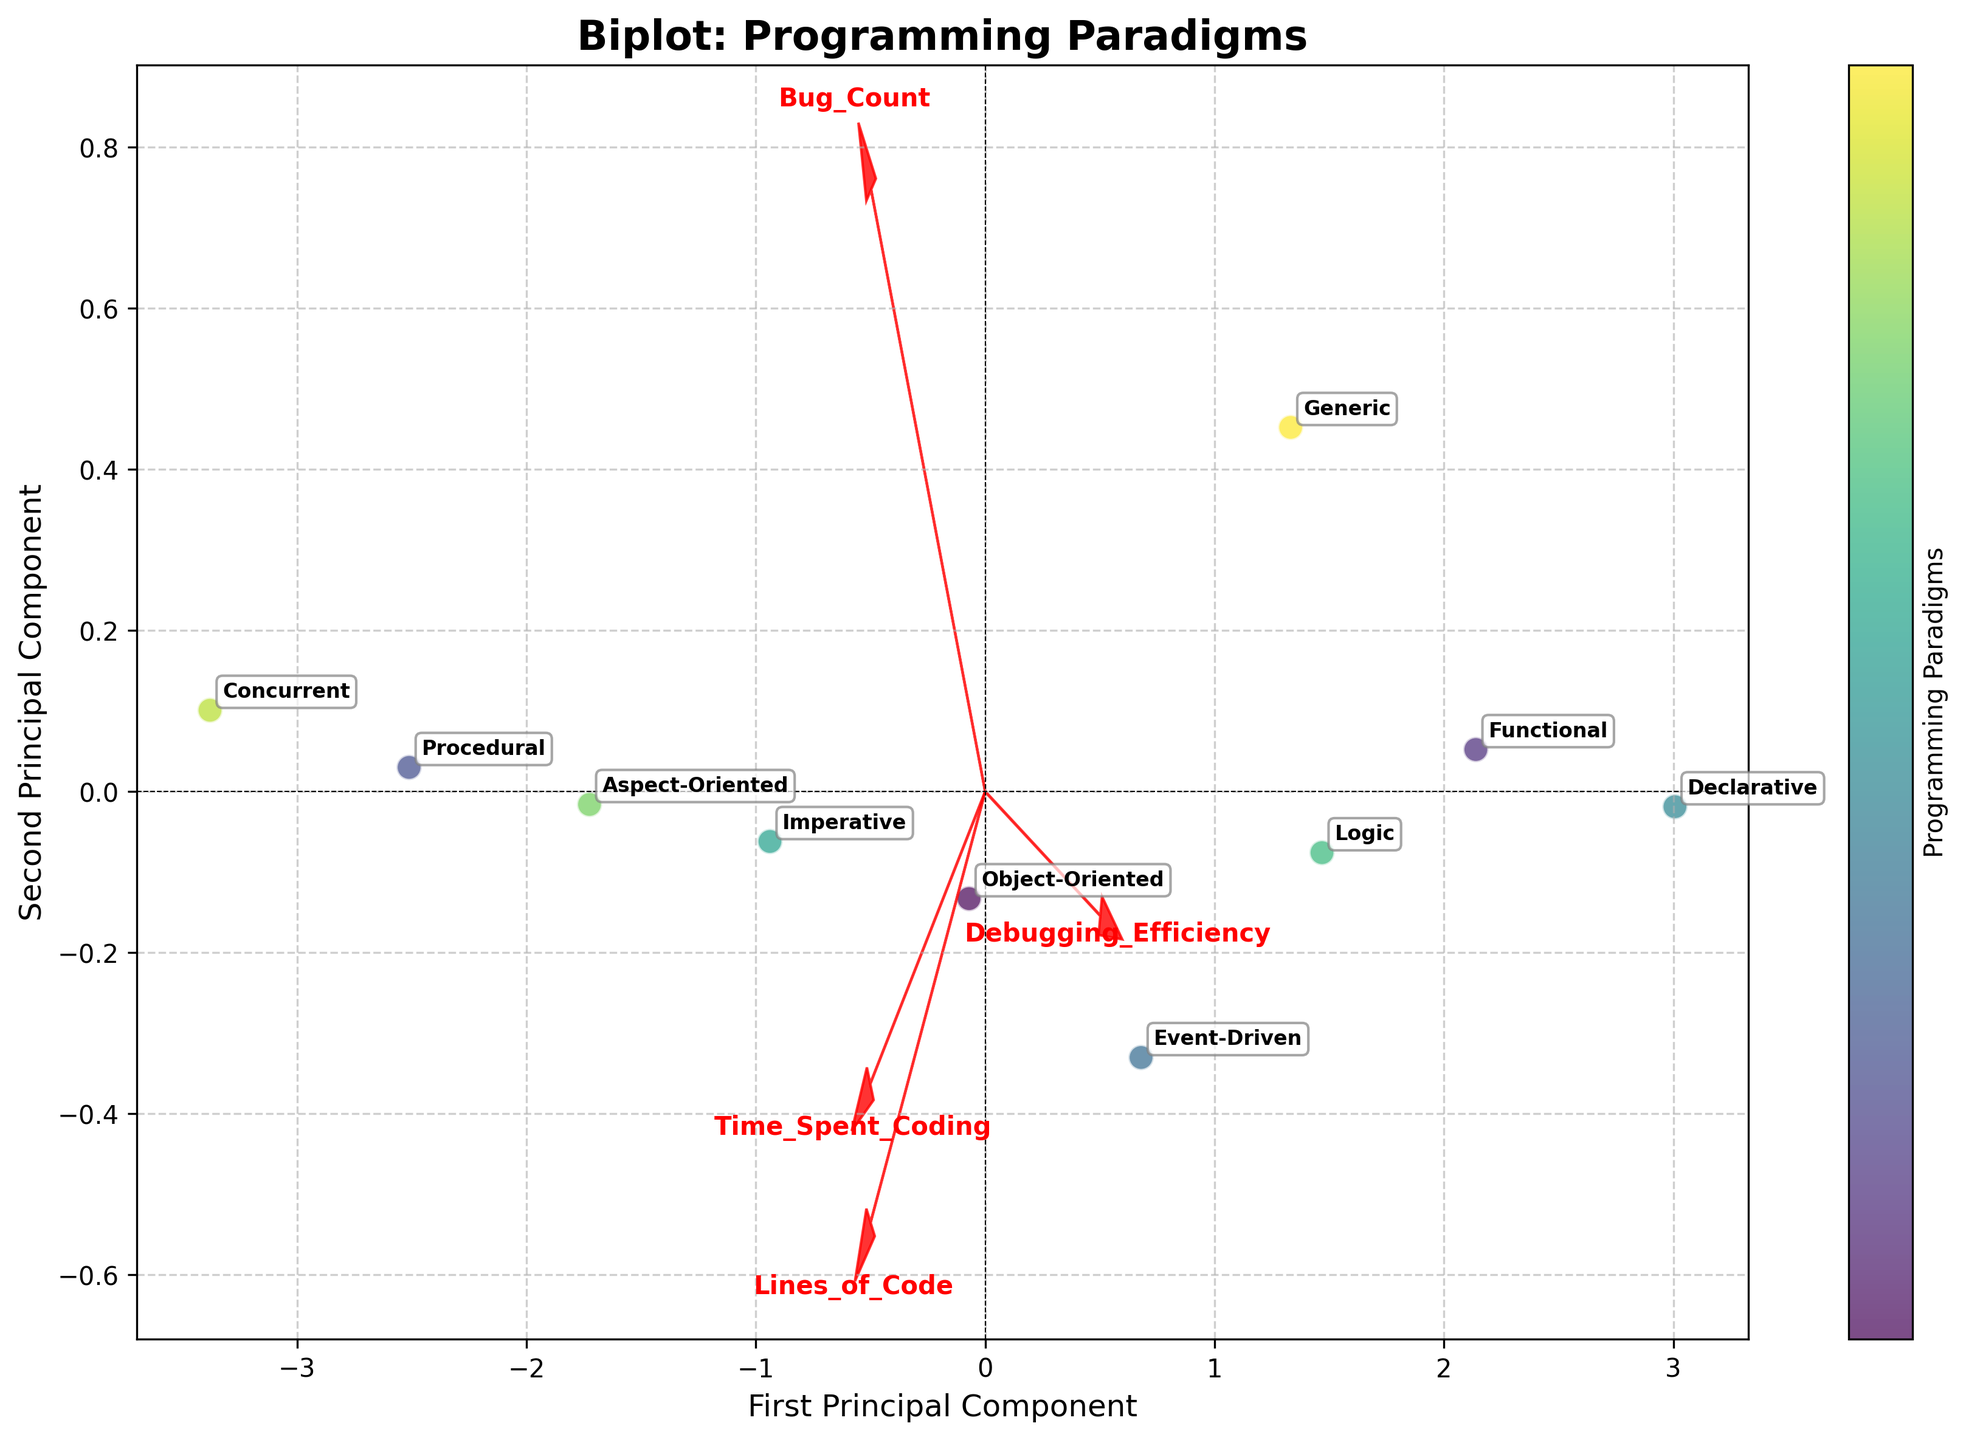What is the title of the plot? The title is found at the top of the plot and describes what the plot is about. In this case, it will mention "Programming Paradigms."
Answer: Biplot: Programming Paradigms How many programming paradigms are represented in the plot? Count the number of unique annotations in the plot that label each data point representing different paradigms.
Answer: 10 Which programming paradigm shows the highest Debugging Efficiency? Look at the positioning of the points relative to the Debugging Efficiency vector. The point furthest along this vector represents the highest Debugging Efficiency.
Answer: Declarative Which programming paradigm has the lowest Debugging Efficiency? Look at the data point that is furthest in the opposite direction to the Debugging Efficiency vector. This will represent the lowest debugging efficiency.
Answer: Concurrent Which feature vectors are plotted in red? The feature vectors are drawn as red arrows pointing out from the origin. Check the labels at the end of the arrows.
Answer: Time Spent Coding, Debugging Efficiency, Lines of Code, Bug Count What is the relationship between Time Spent Coding and Debugging Efficiency? Analyze the directions of the vectors for Time Spent Coding and Debugging Efficiency. The angle between them indicates how they are related. If they point in similar directions, they are positively correlated.
Answer: Slight positive correlation Which programming paradigm is characterized by spending the most amount of time coding? Look for the data point farthest in the direction of the Time Spent Coding vector.
Answer: Concurrent How are the vectors for Lines of Code and Bug Count related? Observe the angles between the vectors for Lines of Code and Bug Count. If they point in similar directions, they suggest a positive correlation; if they are opposite, they suggest a negative correlation.
Answer: Strong positive correlation Which component of the PCA explains more variance? The direction along which the data is more spread out represents the principal component explaining more variance. Check the labels of the axes corresponding to the PCA components.
Answer: First Principal Component Are there any programming paradigms that are close together in principle component space? Look for data points that are plotted near each other on the biplot. Consider these programming paradigms as being close together in terms of principle component space.
Answer: Object-Oriented and Aspect-Oriented 